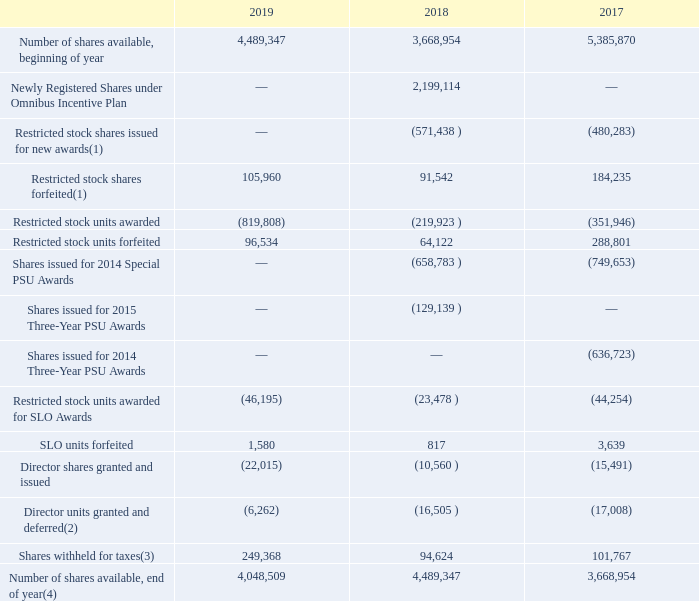A summary of the changes in common shares available for awards under the Omnibus Incentive Plan and Predecessor Plans
follows:
(1) As of December 31, 2018, there were 1,478 restricted stock shares issued for new awards under the Omnibus Incentive Plan and (5,024) restricted stock shares forfeited that were not yet reflected by our Recordkeeper. The table above (shares available under the Omnibus Incentive Plan) reflects this activity as occurred, creating a reconciling difference between shares issued and number of shares available under the Omnibus Plan.
(2) Director units granted and deferred include the impact of share-settled dividends earned and deferred on deferred shares.
(3) The Omnibus Incentive Plan and 2005 Contingent Stock Plan permit withholding of taxes and other charges that may be required by law to be paid attributable to awards by withholding a portion of the shares attributable to such awards.
(4) The above table excludes approximately1.2 million contingently issuable shares under the PSU awards and SLO awards, which represents the maximum number of shares that could be issued under those plans as of December 31, 2019.
We record share-based incentive compensation expense in selling, general and administrative expenses and cost of sales on our Consolidated Statements of Operations for both equity-classified awards and liability-classified awards. We record a corresponding credit to additional paid-in capital within stockholders’ deficit for equity-classified awards, and to either a current or non-current liability for liability-classified awards based on the fair value of the share-based incentive compensation awards at the date of grant. Total expense for the liability-classified awards continues to be remeasured to fair value at the end of each reporting period. We recognize an expense or credit reflecting the straight-line recognition, net of estimated forfeitures, of the expected cost of the program. The number of PSUs earned may equal, exceed or be less than the targeted number of shares depending on whether the performance criteria are met, surpassed or not met.
What does the table represent? Summary of the changes in common shares available for awards under the omnibus incentive plan and predecessor plans. How many restricted stock shares were issued for new awards under the Omnibus Incentive Plan as of December 31, 2018? 1,478. What does the Omnibus Incentive Plan and 2005 Contingent Stock Plan permit? Withholding of taxes and other charges that may be required by law to be paid attributable to awards by withholding a portion of the shares attributable to such awards. What is the percentage difference of shares withheld for taxes for 2018 to 2019?
Answer scale should be: percent. (249,368-94,624)/94,624
Answer: 163.54. What is the Number of shares available, end of year expressed as a percentage of Number of shares available, beginning of year for 2019? 
Answer scale should be: percent. 4,048,509/4,489,347
Answer: 90.18. What is the average annual Number of shares available, end of year for 2017-2019? (4,048,509+4,489,347+3,668,954)/3
Answer: 4068936.67. 